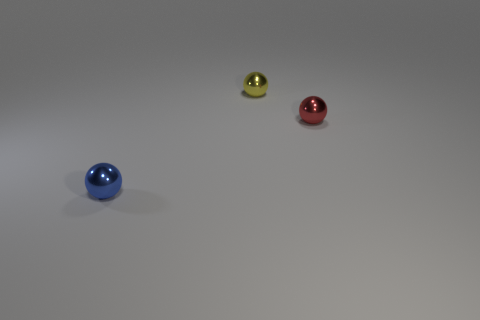Add 3 big gray rubber objects. How many objects exist? 6 Subtract all red objects. Subtract all small red spheres. How many objects are left? 1 Add 2 blue metallic objects. How many blue metallic objects are left? 3 Add 1 large green metallic things. How many large green metallic things exist? 1 Subtract 0 gray cylinders. How many objects are left? 3 